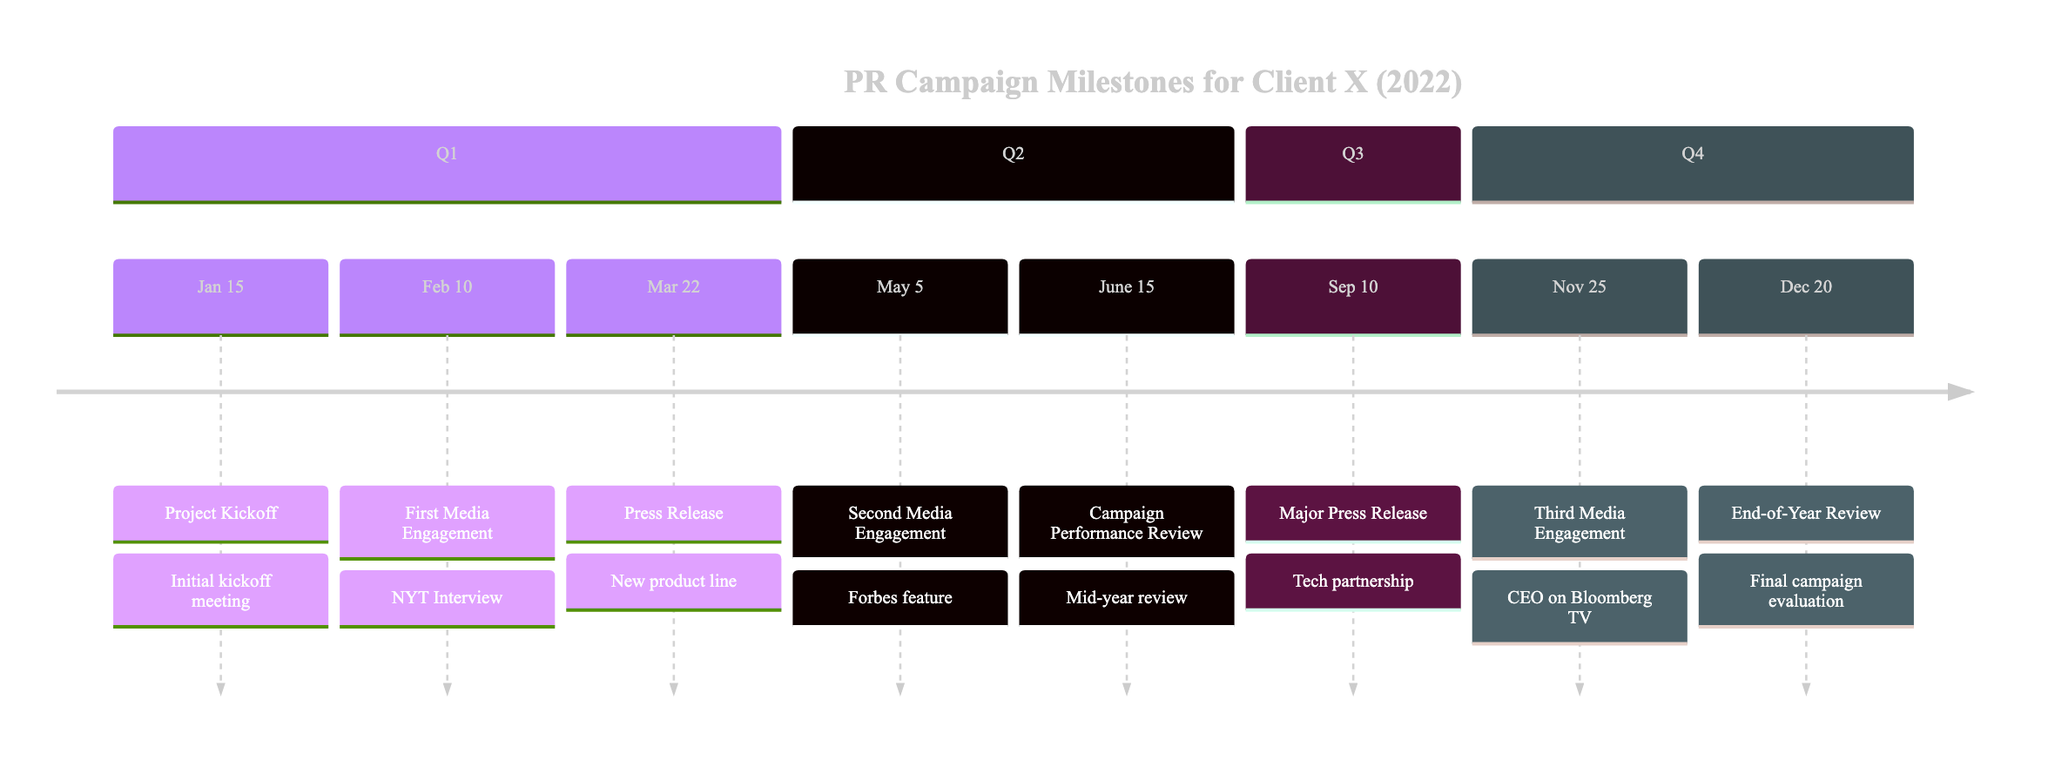What is the first milestone in the timeline? The first milestone is the "Project Kickoff," which is listed at the start of the timeline in January.
Answer: Project Kickoff How many media engagements are there in 2022? Counting the instances labeled as "Media Engagement," there are three occurrences in the timeline: the First, Second, and Third Media Engagements.
Answer: 3 What date was the major press release in the timeline? The major press release is indicated on September 10 in the timeline, which corresponds to the announcement of a partnership with a tech company.
Answer: September 10 What was discussed during the second media engagement? The second media engagement is characterized by an exclusive feature with Forbes discussing Client X's industry leadership and innovation.
Answer: Forbes feature What type of event occurred on June 15? The event on June 15 is a "Campaign Performance Review," which indicates a mid-year assessment of the campaign's effectiveness.
Answer: Campaign Performance Review How many events occurred in the third quarter (Q3)? According to the timeline, there is only one event listed in Q3, which is the major press release dated September 10.
Answer: 1 Which media outlet was involved in the first media engagement? The first media engagement took place with The New York Times, as noted in the description of that milestone.
Answer: The New York Times When was the final campaign evaluation conducted? The end-of-year campaign performance review is documented on December 20, which is when the final evaluation occurred.
Answer: December 20 What is the significance of the date January 15 in the timeline? January 15 marks the "Project Kickoff," highlighting the initial meeting to discuss campaign strategies and objectives for Client X.
Answer: Project Kickoff 